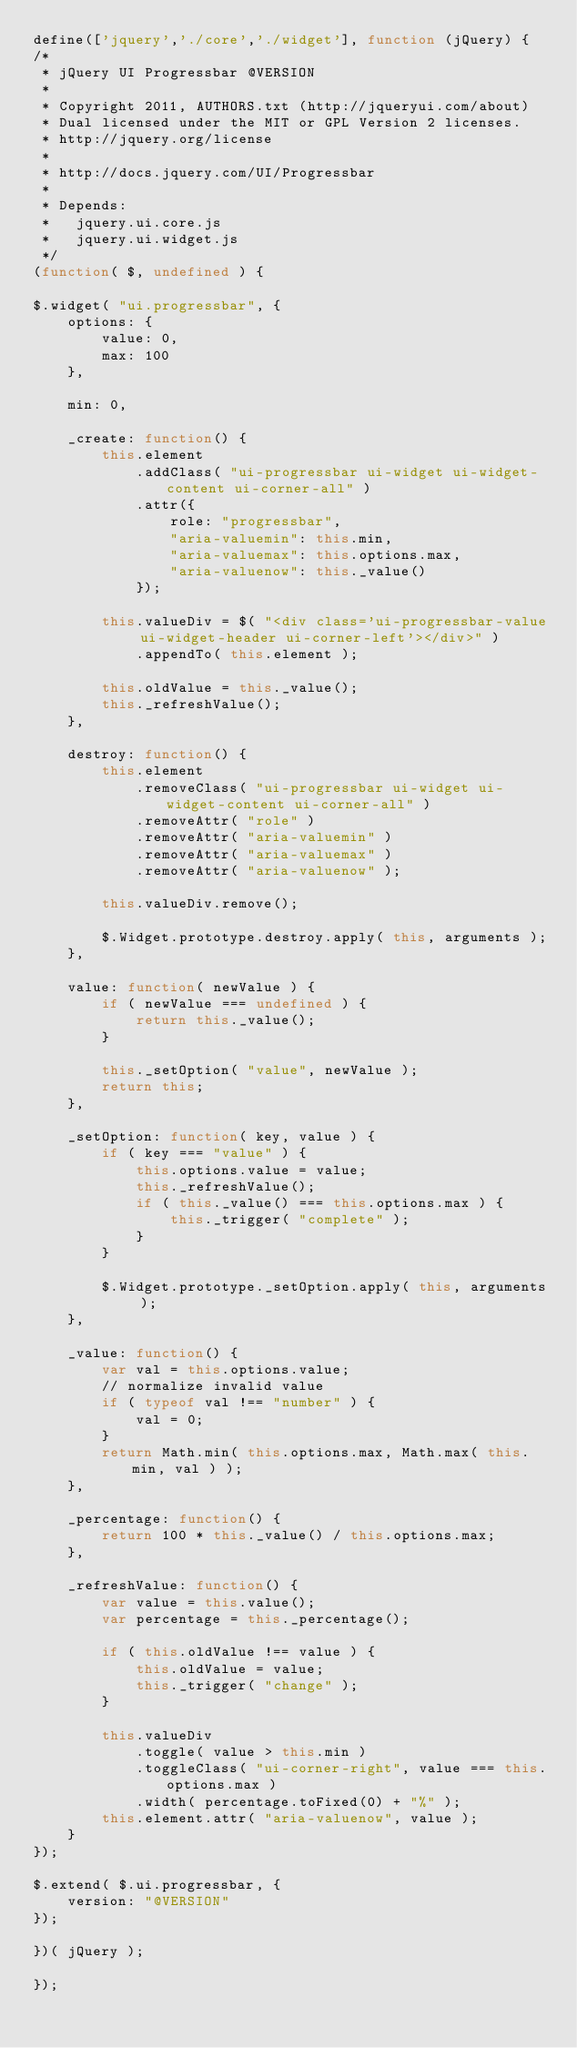Convert code to text. <code><loc_0><loc_0><loc_500><loc_500><_JavaScript_>define(['jquery','./core','./widget'], function (jQuery) {
/*
 * jQuery UI Progressbar @VERSION
 *
 * Copyright 2011, AUTHORS.txt (http://jqueryui.com/about)
 * Dual licensed under the MIT or GPL Version 2 licenses.
 * http://jquery.org/license
 *
 * http://docs.jquery.com/UI/Progressbar
 *
 * Depends:
 *   jquery.ui.core.js
 *   jquery.ui.widget.js
 */
(function( $, undefined ) {

$.widget( "ui.progressbar", {
	options: {
		value: 0,
		max: 100
	},

	min: 0,

	_create: function() {
		this.element
			.addClass( "ui-progressbar ui-widget ui-widget-content ui-corner-all" )
			.attr({
				role: "progressbar",
				"aria-valuemin": this.min,
				"aria-valuemax": this.options.max,
				"aria-valuenow": this._value()
			});

		this.valueDiv = $( "<div class='ui-progressbar-value ui-widget-header ui-corner-left'></div>" )
			.appendTo( this.element );

		this.oldValue = this._value();
		this._refreshValue();
	},

	destroy: function() {
		this.element
			.removeClass( "ui-progressbar ui-widget ui-widget-content ui-corner-all" )
			.removeAttr( "role" )
			.removeAttr( "aria-valuemin" )
			.removeAttr( "aria-valuemax" )
			.removeAttr( "aria-valuenow" );

		this.valueDiv.remove();

		$.Widget.prototype.destroy.apply( this, arguments );
	},

	value: function( newValue ) {
		if ( newValue === undefined ) {
			return this._value();
		}

		this._setOption( "value", newValue );
		return this;
	},

	_setOption: function( key, value ) {
		if ( key === "value" ) {
			this.options.value = value;
			this._refreshValue();
			if ( this._value() === this.options.max ) {
				this._trigger( "complete" );
			}
		}

		$.Widget.prototype._setOption.apply( this, arguments );
	},

	_value: function() {
		var val = this.options.value;
		// normalize invalid value
		if ( typeof val !== "number" ) {
			val = 0;
		}
		return Math.min( this.options.max, Math.max( this.min, val ) );
	},

	_percentage: function() {
		return 100 * this._value() / this.options.max;
	},

	_refreshValue: function() {
		var value = this.value();
		var percentage = this._percentage();

		if ( this.oldValue !== value ) {
			this.oldValue = value;
			this._trigger( "change" );
		}

		this.valueDiv
			.toggle( value > this.min )
			.toggleClass( "ui-corner-right", value === this.options.max )
			.width( percentage.toFixed(0) + "%" );
		this.element.attr( "aria-valuenow", value );
	}
});

$.extend( $.ui.progressbar, {
	version: "@VERSION"
});

})( jQuery );

});</code> 